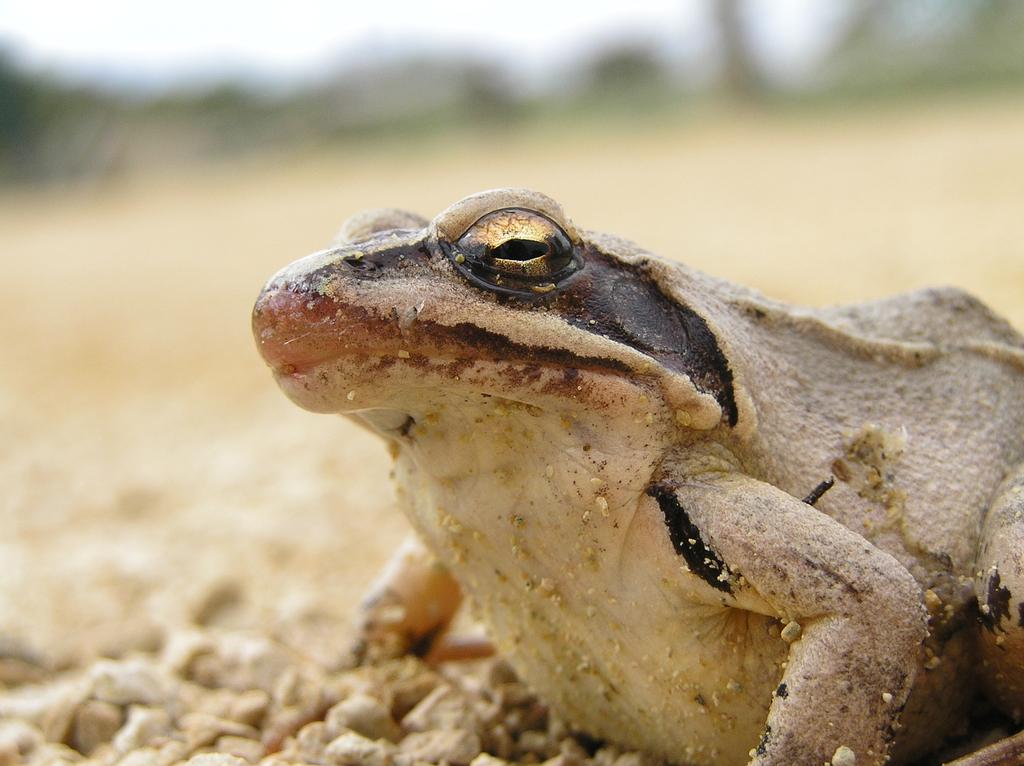What animal is present in the image? There is a frog in the image. What colors can be seen on the frog? The frog is brown and cream in color. What is the frog standing on in the image? The frog is on stones. Can you describe the background of the image? The background of the image is blurred. What type of card is the frog holding in the image? There is no card present in the image; the frog is simply standing on stones. 